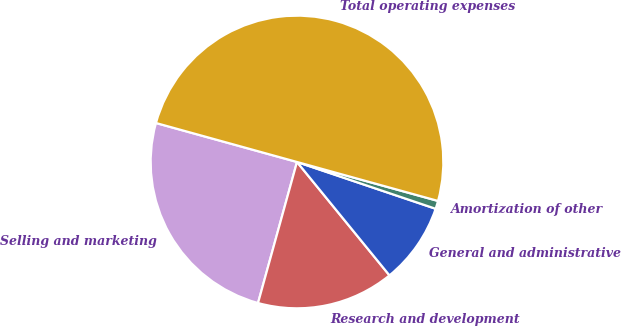Convert chart to OTSL. <chart><loc_0><loc_0><loc_500><loc_500><pie_chart><fcel>Selling and marketing<fcel>Research and development<fcel>General and administrative<fcel>Amortization of other<fcel>Total operating expenses<nl><fcel>25.0%<fcel>15.18%<fcel>8.93%<fcel>0.89%<fcel>50.0%<nl></chart> 